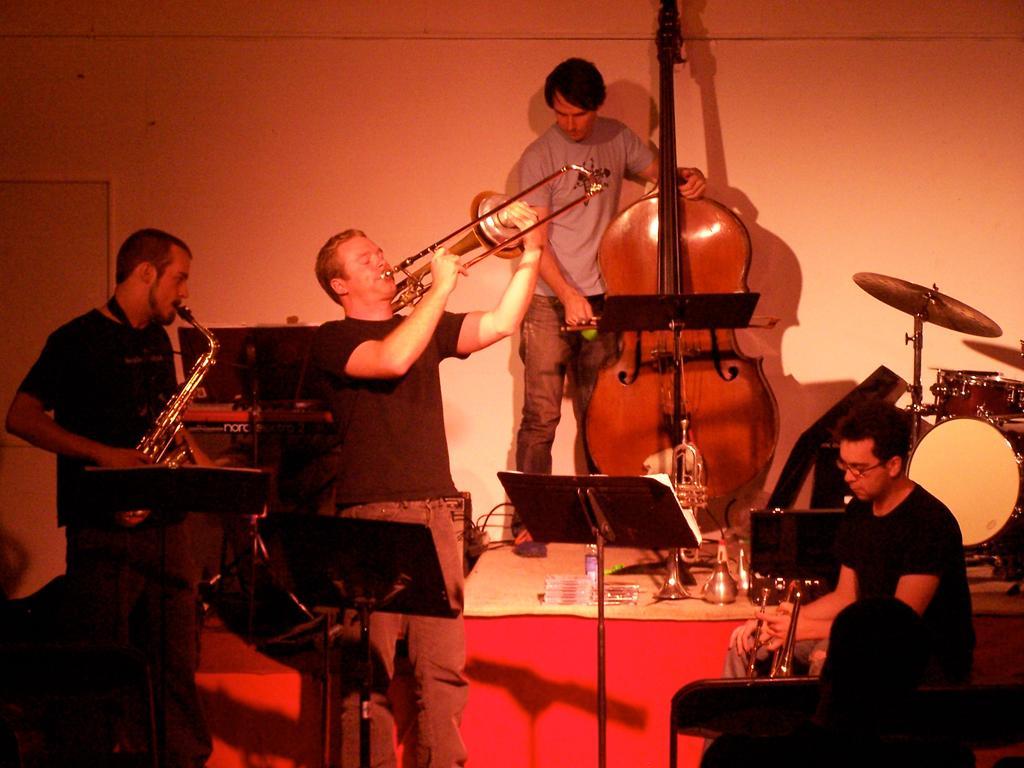How would you summarize this image in a sentence or two? In this image we can see men standing on the floor and holding musical instruments in their hands. In addition to this we can see a book stand and walls. 